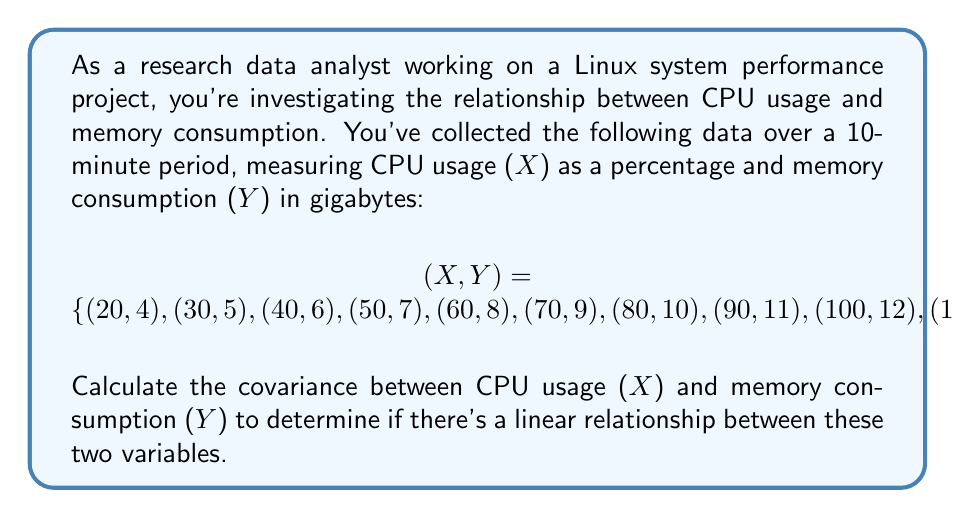Teach me how to tackle this problem. To calculate the covariance between CPU usage (X) and memory consumption (Y), we'll follow these steps:

1. Calculate the means of X and Y:
   $$\bar{X} = \frac{20 + 30 + 40 + 50 + 60 + 70 + 80 + 90 + 100 + 110}{10} = 65$$
   $$\bar{Y} = \frac{4 + 5 + 6 + 7 + 8 + 9 + 10 + 11 + 12 + 13}{10} = 8.5$$

2. Calculate $(X_i - \bar{X})(Y_i - \bar{Y})$ for each pair of observations:
   $$(20 - 65)(4 - 8.5) = 202.5$$
   $$(30 - 65)(5 - 8.5) = 122.5$$
   $$(40 - 65)(6 - 8.5) = 62.5$$
   $$(50 - 65)(7 - 8.5) = 22.5$$
   $$(60 - 65)(8 - 8.5) = 2.5$$
   $$(70 - 65)(9 - 8.5) = 2.5$$
   $$(80 - 65)(10 - 8.5) = 22.5$$
   $$(90 - 65)(11 - 8.5) = 62.5$$
   $$(100 - 65)(12 - 8.5) = 122.5$$
   $$(110 - 65)(13 - 8.5) = 202.5$$

3. Sum the results from step 2:
   $$\sum_{i=1}^{n} (X_i - \bar{X})(Y_i - \bar{Y}) = 825$$

4. Divide by (n-1) to get the covariance:
   $$Cov(X,Y) = \frac{1}{n-1} \sum_{i=1}^{n} (X_i - \bar{X})(Y_i - \bar{Y})$$
   $$Cov(X,Y) = \frac{825}{9} = 91.67$$

The positive covariance indicates a positive linear relationship between CPU usage and memory consumption in this Linux system.
Answer: The covariance between CPU usage (X) and memory consumption (Y) is $91.67$. 